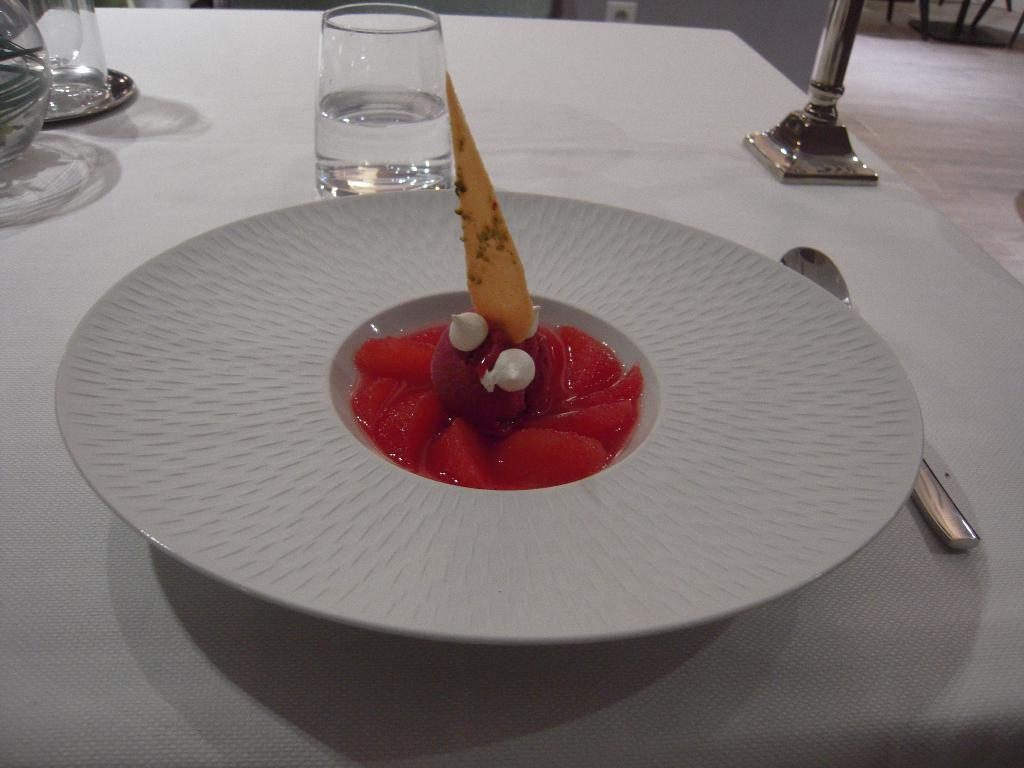What is on the plate that is visible in the image? There is a plate with food in the image. What else can be seen on the table besides the plate? There are glasses visible in the image. What is the object on the table? There is an object on the table, but its specific nature is not mentioned in the facts. What is the table resting on? The table is on the floor. What is visible behind the table in the image? There is a wall visible in the image. How many birds are flying around the plate of food in the image? There are no birds visible in the image. What type of earth is shown in the image? The image does not depict any earth or soil; it features a table with a plate, glasses, and an object. 